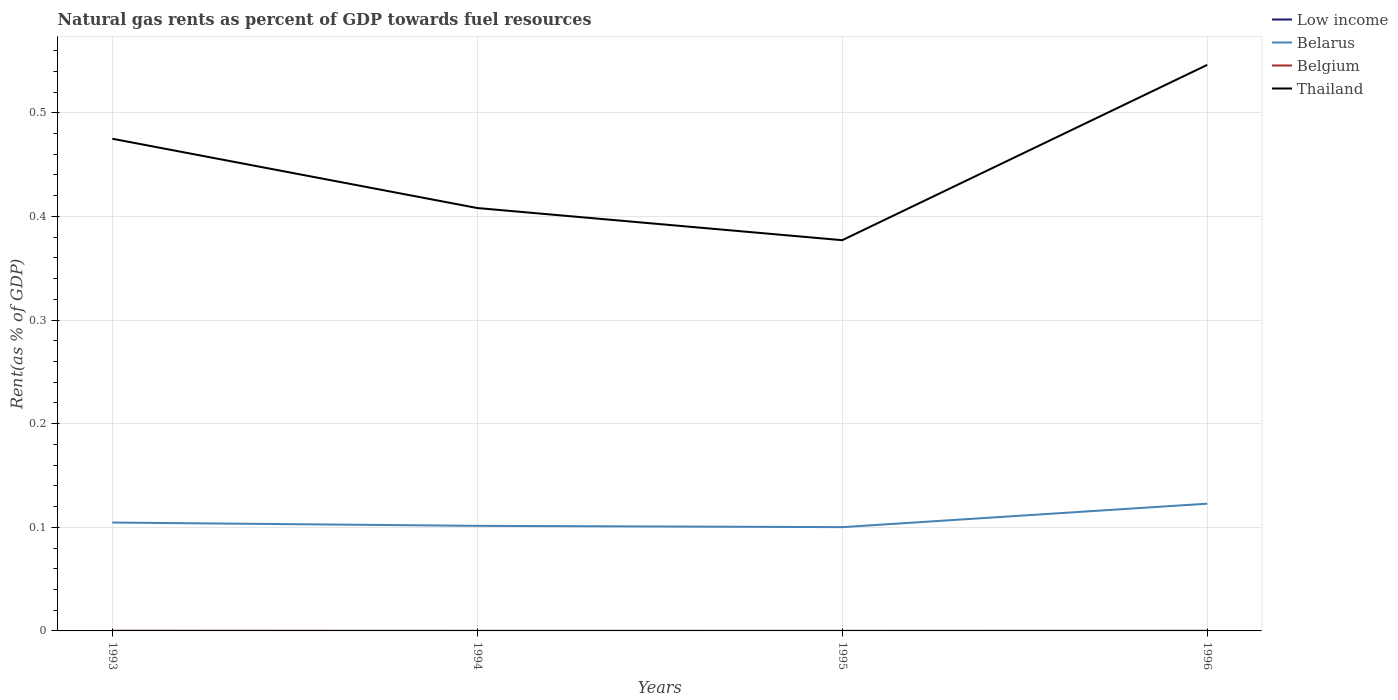Across all years, what is the maximum matural gas rent in Thailand?
Ensure brevity in your answer.  0.38. In which year was the matural gas rent in Belarus maximum?
Offer a terse response. 1995. What is the total matural gas rent in Belarus in the graph?
Give a very brief answer. 0. What is the difference between the highest and the second highest matural gas rent in Low income?
Make the answer very short. 2.01702983193908e-5. How many years are there in the graph?
Provide a succinct answer. 4. What is the difference between two consecutive major ticks on the Y-axis?
Your answer should be compact. 0.1. Are the values on the major ticks of Y-axis written in scientific E-notation?
Offer a very short reply. No. Where does the legend appear in the graph?
Offer a very short reply. Top right. How are the legend labels stacked?
Your answer should be very brief. Vertical. What is the title of the graph?
Provide a short and direct response. Natural gas rents as percent of GDP towards fuel resources. What is the label or title of the X-axis?
Provide a short and direct response. Years. What is the label or title of the Y-axis?
Ensure brevity in your answer.  Rent(as % of GDP). What is the Rent(as % of GDP) in Low income in 1993?
Offer a terse response. 1.98169078129084e-5. What is the Rent(as % of GDP) of Belarus in 1993?
Your answer should be very brief. 0.1. What is the Rent(as % of GDP) of Belgium in 1993?
Give a very brief answer. 0. What is the Rent(as % of GDP) of Thailand in 1993?
Make the answer very short. 0.47. What is the Rent(as % of GDP) of Low income in 1994?
Offer a terse response. 1.66764618261871e-5. What is the Rent(as % of GDP) in Belarus in 1994?
Provide a short and direct response. 0.1. What is the Rent(as % of GDP) in Belgium in 1994?
Provide a succinct answer. 2.3325831611504e-5. What is the Rent(as % of GDP) in Thailand in 1994?
Provide a succinct answer. 0.41. What is the Rent(as % of GDP) of Low income in 1995?
Offer a very short reply. 3.1650228781704e-5. What is the Rent(as % of GDP) in Belarus in 1995?
Make the answer very short. 0.1. What is the Rent(as % of GDP) of Belgium in 1995?
Provide a short and direct response. 4.71149588328275e-6. What is the Rent(as % of GDP) in Thailand in 1995?
Your response must be concise. 0.38. What is the Rent(as % of GDP) of Low income in 1996?
Make the answer very short. 3.68467601455779e-5. What is the Rent(as % of GDP) of Belarus in 1996?
Offer a terse response. 0.12. What is the Rent(as % of GDP) of Belgium in 1996?
Your answer should be compact. 5.3675418688014e-5. What is the Rent(as % of GDP) of Thailand in 1996?
Offer a very short reply. 0.55. Across all years, what is the maximum Rent(as % of GDP) of Low income?
Give a very brief answer. 3.68467601455779e-5. Across all years, what is the maximum Rent(as % of GDP) in Belarus?
Ensure brevity in your answer.  0.12. Across all years, what is the maximum Rent(as % of GDP) of Belgium?
Keep it short and to the point. 0. Across all years, what is the maximum Rent(as % of GDP) of Thailand?
Provide a short and direct response. 0.55. Across all years, what is the minimum Rent(as % of GDP) of Low income?
Provide a short and direct response. 1.66764618261871e-5. Across all years, what is the minimum Rent(as % of GDP) of Belarus?
Your answer should be very brief. 0.1. Across all years, what is the minimum Rent(as % of GDP) in Belgium?
Your response must be concise. 4.71149588328275e-6. Across all years, what is the minimum Rent(as % of GDP) of Thailand?
Keep it short and to the point. 0.38. What is the total Rent(as % of GDP) of Low income in the graph?
Your answer should be very brief. 0. What is the total Rent(as % of GDP) of Belarus in the graph?
Offer a very short reply. 0.43. What is the total Rent(as % of GDP) in Belgium in the graph?
Provide a succinct answer. 0. What is the total Rent(as % of GDP) in Thailand in the graph?
Keep it short and to the point. 1.81. What is the difference between the Rent(as % of GDP) of Low income in 1993 and that in 1994?
Offer a terse response. 0. What is the difference between the Rent(as % of GDP) in Belarus in 1993 and that in 1994?
Make the answer very short. 0. What is the difference between the Rent(as % of GDP) in Thailand in 1993 and that in 1994?
Make the answer very short. 0.07. What is the difference between the Rent(as % of GDP) of Belarus in 1993 and that in 1995?
Your answer should be compact. 0. What is the difference between the Rent(as % of GDP) of Thailand in 1993 and that in 1995?
Your answer should be compact. 0.1. What is the difference between the Rent(as % of GDP) of Belarus in 1993 and that in 1996?
Provide a succinct answer. -0.02. What is the difference between the Rent(as % of GDP) of Belgium in 1993 and that in 1996?
Offer a terse response. 0. What is the difference between the Rent(as % of GDP) in Thailand in 1993 and that in 1996?
Your answer should be compact. -0.07. What is the difference between the Rent(as % of GDP) in Low income in 1994 and that in 1995?
Keep it short and to the point. -0. What is the difference between the Rent(as % of GDP) in Belarus in 1994 and that in 1995?
Offer a very short reply. 0. What is the difference between the Rent(as % of GDP) of Thailand in 1994 and that in 1995?
Make the answer very short. 0.03. What is the difference between the Rent(as % of GDP) of Belarus in 1994 and that in 1996?
Keep it short and to the point. -0.02. What is the difference between the Rent(as % of GDP) of Thailand in 1994 and that in 1996?
Ensure brevity in your answer.  -0.14. What is the difference between the Rent(as % of GDP) of Low income in 1995 and that in 1996?
Offer a very short reply. -0. What is the difference between the Rent(as % of GDP) in Belarus in 1995 and that in 1996?
Your response must be concise. -0.02. What is the difference between the Rent(as % of GDP) of Belgium in 1995 and that in 1996?
Offer a terse response. -0. What is the difference between the Rent(as % of GDP) in Thailand in 1995 and that in 1996?
Make the answer very short. -0.17. What is the difference between the Rent(as % of GDP) of Low income in 1993 and the Rent(as % of GDP) of Belarus in 1994?
Give a very brief answer. -0.1. What is the difference between the Rent(as % of GDP) of Low income in 1993 and the Rent(as % of GDP) of Thailand in 1994?
Offer a terse response. -0.41. What is the difference between the Rent(as % of GDP) in Belarus in 1993 and the Rent(as % of GDP) in Belgium in 1994?
Give a very brief answer. 0.1. What is the difference between the Rent(as % of GDP) in Belarus in 1993 and the Rent(as % of GDP) in Thailand in 1994?
Provide a short and direct response. -0.3. What is the difference between the Rent(as % of GDP) of Belgium in 1993 and the Rent(as % of GDP) of Thailand in 1994?
Provide a succinct answer. -0.41. What is the difference between the Rent(as % of GDP) of Low income in 1993 and the Rent(as % of GDP) of Belarus in 1995?
Make the answer very short. -0.1. What is the difference between the Rent(as % of GDP) in Low income in 1993 and the Rent(as % of GDP) in Belgium in 1995?
Offer a terse response. 0. What is the difference between the Rent(as % of GDP) of Low income in 1993 and the Rent(as % of GDP) of Thailand in 1995?
Offer a terse response. -0.38. What is the difference between the Rent(as % of GDP) of Belarus in 1993 and the Rent(as % of GDP) of Belgium in 1995?
Ensure brevity in your answer.  0.1. What is the difference between the Rent(as % of GDP) in Belarus in 1993 and the Rent(as % of GDP) in Thailand in 1995?
Give a very brief answer. -0.27. What is the difference between the Rent(as % of GDP) of Belgium in 1993 and the Rent(as % of GDP) of Thailand in 1995?
Provide a succinct answer. -0.38. What is the difference between the Rent(as % of GDP) of Low income in 1993 and the Rent(as % of GDP) of Belarus in 1996?
Offer a terse response. -0.12. What is the difference between the Rent(as % of GDP) in Low income in 1993 and the Rent(as % of GDP) in Thailand in 1996?
Provide a short and direct response. -0.55. What is the difference between the Rent(as % of GDP) in Belarus in 1993 and the Rent(as % of GDP) in Belgium in 1996?
Offer a very short reply. 0.1. What is the difference between the Rent(as % of GDP) of Belarus in 1993 and the Rent(as % of GDP) of Thailand in 1996?
Provide a succinct answer. -0.44. What is the difference between the Rent(as % of GDP) in Belgium in 1993 and the Rent(as % of GDP) in Thailand in 1996?
Keep it short and to the point. -0.55. What is the difference between the Rent(as % of GDP) of Low income in 1994 and the Rent(as % of GDP) of Belarus in 1995?
Offer a terse response. -0.1. What is the difference between the Rent(as % of GDP) in Low income in 1994 and the Rent(as % of GDP) in Thailand in 1995?
Provide a succinct answer. -0.38. What is the difference between the Rent(as % of GDP) in Belarus in 1994 and the Rent(as % of GDP) in Belgium in 1995?
Your response must be concise. 0.1. What is the difference between the Rent(as % of GDP) in Belarus in 1994 and the Rent(as % of GDP) in Thailand in 1995?
Keep it short and to the point. -0.28. What is the difference between the Rent(as % of GDP) of Belgium in 1994 and the Rent(as % of GDP) of Thailand in 1995?
Your answer should be very brief. -0.38. What is the difference between the Rent(as % of GDP) of Low income in 1994 and the Rent(as % of GDP) of Belarus in 1996?
Provide a succinct answer. -0.12. What is the difference between the Rent(as % of GDP) in Low income in 1994 and the Rent(as % of GDP) in Belgium in 1996?
Offer a terse response. -0. What is the difference between the Rent(as % of GDP) of Low income in 1994 and the Rent(as % of GDP) of Thailand in 1996?
Provide a short and direct response. -0.55. What is the difference between the Rent(as % of GDP) of Belarus in 1994 and the Rent(as % of GDP) of Belgium in 1996?
Provide a short and direct response. 0.1. What is the difference between the Rent(as % of GDP) in Belarus in 1994 and the Rent(as % of GDP) in Thailand in 1996?
Your answer should be compact. -0.44. What is the difference between the Rent(as % of GDP) of Belgium in 1994 and the Rent(as % of GDP) of Thailand in 1996?
Keep it short and to the point. -0.55. What is the difference between the Rent(as % of GDP) of Low income in 1995 and the Rent(as % of GDP) of Belarus in 1996?
Your answer should be compact. -0.12. What is the difference between the Rent(as % of GDP) of Low income in 1995 and the Rent(as % of GDP) of Thailand in 1996?
Give a very brief answer. -0.55. What is the difference between the Rent(as % of GDP) of Belarus in 1995 and the Rent(as % of GDP) of Belgium in 1996?
Keep it short and to the point. 0.1. What is the difference between the Rent(as % of GDP) in Belarus in 1995 and the Rent(as % of GDP) in Thailand in 1996?
Provide a succinct answer. -0.45. What is the difference between the Rent(as % of GDP) of Belgium in 1995 and the Rent(as % of GDP) of Thailand in 1996?
Ensure brevity in your answer.  -0.55. What is the average Rent(as % of GDP) of Low income per year?
Ensure brevity in your answer.  0. What is the average Rent(as % of GDP) in Belarus per year?
Keep it short and to the point. 0.11. What is the average Rent(as % of GDP) in Belgium per year?
Offer a very short reply. 0. What is the average Rent(as % of GDP) in Thailand per year?
Offer a very short reply. 0.45. In the year 1993, what is the difference between the Rent(as % of GDP) in Low income and Rent(as % of GDP) in Belarus?
Make the answer very short. -0.1. In the year 1993, what is the difference between the Rent(as % of GDP) of Low income and Rent(as % of GDP) of Belgium?
Your answer should be very brief. -0. In the year 1993, what is the difference between the Rent(as % of GDP) of Low income and Rent(as % of GDP) of Thailand?
Your response must be concise. -0.47. In the year 1993, what is the difference between the Rent(as % of GDP) in Belarus and Rent(as % of GDP) in Belgium?
Make the answer very short. 0.1. In the year 1993, what is the difference between the Rent(as % of GDP) of Belarus and Rent(as % of GDP) of Thailand?
Make the answer very short. -0.37. In the year 1993, what is the difference between the Rent(as % of GDP) in Belgium and Rent(as % of GDP) in Thailand?
Your response must be concise. -0.47. In the year 1994, what is the difference between the Rent(as % of GDP) of Low income and Rent(as % of GDP) of Belarus?
Ensure brevity in your answer.  -0.1. In the year 1994, what is the difference between the Rent(as % of GDP) of Low income and Rent(as % of GDP) of Thailand?
Offer a terse response. -0.41. In the year 1994, what is the difference between the Rent(as % of GDP) in Belarus and Rent(as % of GDP) in Belgium?
Provide a short and direct response. 0.1. In the year 1994, what is the difference between the Rent(as % of GDP) of Belarus and Rent(as % of GDP) of Thailand?
Give a very brief answer. -0.31. In the year 1994, what is the difference between the Rent(as % of GDP) of Belgium and Rent(as % of GDP) of Thailand?
Your response must be concise. -0.41. In the year 1995, what is the difference between the Rent(as % of GDP) of Low income and Rent(as % of GDP) of Belarus?
Offer a terse response. -0.1. In the year 1995, what is the difference between the Rent(as % of GDP) in Low income and Rent(as % of GDP) in Belgium?
Your answer should be compact. 0. In the year 1995, what is the difference between the Rent(as % of GDP) in Low income and Rent(as % of GDP) in Thailand?
Your answer should be very brief. -0.38. In the year 1995, what is the difference between the Rent(as % of GDP) in Belarus and Rent(as % of GDP) in Belgium?
Keep it short and to the point. 0.1. In the year 1995, what is the difference between the Rent(as % of GDP) in Belarus and Rent(as % of GDP) in Thailand?
Your response must be concise. -0.28. In the year 1995, what is the difference between the Rent(as % of GDP) in Belgium and Rent(as % of GDP) in Thailand?
Provide a succinct answer. -0.38. In the year 1996, what is the difference between the Rent(as % of GDP) in Low income and Rent(as % of GDP) in Belarus?
Ensure brevity in your answer.  -0.12. In the year 1996, what is the difference between the Rent(as % of GDP) in Low income and Rent(as % of GDP) in Belgium?
Your answer should be very brief. -0. In the year 1996, what is the difference between the Rent(as % of GDP) in Low income and Rent(as % of GDP) in Thailand?
Provide a short and direct response. -0.55. In the year 1996, what is the difference between the Rent(as % of GDP) of Belarus and Rent(as % of GDP) of Belgium?
Make the answer very short. 0.12. In the year 1996, what is the difference between the Rent(as % of GDP) in Belarus and Rent(as % of GDP) in Thailand?
Provide a succinct answer. -0.42. In the year 1996, what is the difference between the Rent(as % of GDP) of Belgium and Rent(as % of GDP) of Thailand?
Your answer should be very brief. -0.55. What is the ratio of the Rent(as % of GDP) of Low income in 1993 to that in 1994?
Give a very brief answer. 1.19. What is the ratio of the Rent(as % of GDP) of Belarus in 1993 to that in 1994?
Provide a short and direct response. 1.03. What is the ratio of the Rent(as % of GDP) in Belgium in 1993 to that in 1994?
Your answer should be compact. 5.12. What is the ratio of the Rent(as % of GDP) of Thailand in 1993 to that in 1994?
Ensure brevity in your answer.  1.16. What is the ratio of the Rent(as % of GDP) in Low income in 1993 to that in 1995?
Give a very brief answer. 0.63. What is the ratio of the Rent(as % of GDP) of Belarus in 1993 to that in 1995?
Make the answer very short. 1.04. What is the ratio of the Rent(as % of GDP) of Belgium in 1993 to that in 1995?
Offer a terse response. 25.37. What is the ratio of the Rent(as % of GDP) of Thailand in 1993 to that in 1995?
Keep it short and to the point. 1.26. What is the ratio of the Rent(as % of GDP) in Low income in 1993 to that in 1996?
Your answer should be very brief. 0.54. What is the ratio of the Rent(as % of GDP) in Belarus in 1993 to that in 1996?
Keep it short and to the point. 0.85. What is the ratio of the Rent(as % of GDP) of Belgium in 1993 to that in 1996?
Offer a terse response. 2.23. What is the ratio of the Rent(as % of GDP) in Thailand in 1993 to that in 1996?
Your answer should be very brief. 0.87. What is the ratio of the Rent(as % of GDP) of Low income in 1994 to that in 1995?
Make the answer very short. 0.53. What is the ratio of the Rent(as % of GDP) of Belarus in 1994 to that in 1995?
Your answer should be very brief. 1.01. What is the ratio of the Rent(as % of GDP) of Belgium in 1994 to that in 1995?
Make the answer very short. 4.95. What is the ratio of the Rent(as % of GDP) in Thailand in 1994 to that in 1995?
Ensure brevity in your answer.  1.08. What is the ratio of the Rent(as % of GDP) of Low income in 1994 to that in 1996?
Provide a succinct answer. 0.45. What is the ratio of the Rent(as % of GDP) in Belarus in 1994 to that in 1996?
Your answer should be compact. 0.83. What is the ratio of the Rent(as % of GDP) in Belgium in 1994 to that in 1996?
Give a very brief answer. 0.43. What is the ratio of the Rent(as % of GDP) of Thailand in 1994 to that in 1996?
Provide a short and direct response. 0.75. What is the ratio of the Rent(as % of GDP) of Low income in 1995 to that in 1996?
Ensure brevity in your answer.  0.86. What is the ratio of the Rent(as % of GDP) in Belarus in 1995 to that in 1996?
Provide a succinct answer. 0.82. What is the ratio of the Rent(as % of GDP) in Belgium in 1995 to that in 1996?
Provide a succinct answer. 0.09. What is the ratio of the Rent(as % of GDP) of Thailand in 1995 to that in 1996?
Provide a succinct answer. 0.69. What is the difference between the highest and the second highest Rent(as % of GDP) in Belarus?
Provide a short and direct response. 0.02. What is the difference between the highest and the second highest Rent(as % of GDP) in Belgium?
Keep it short and to the point. 0. What is the difference between the highest and the second highest Rent(as % of GDP) of Thailand?
Provide a succinct answer. 0.07. What is the difference between the highest and the lowest Rent(as % of GDP) of Low income?
Provide a short and direct response. 0. What is the difference between the highest and the lowest Rent(as % of GDP) of Belarus?
Your answer should be very brief. 0.02. What is the difference between the highest and the lowest Rent(as % of GDP) in Belgium?
Keep it short and to the point. 0. What is the difference between the highest and the lowest Rent(as % of GDP) in Thailand?
Provide a succinct answer. 0.17. 